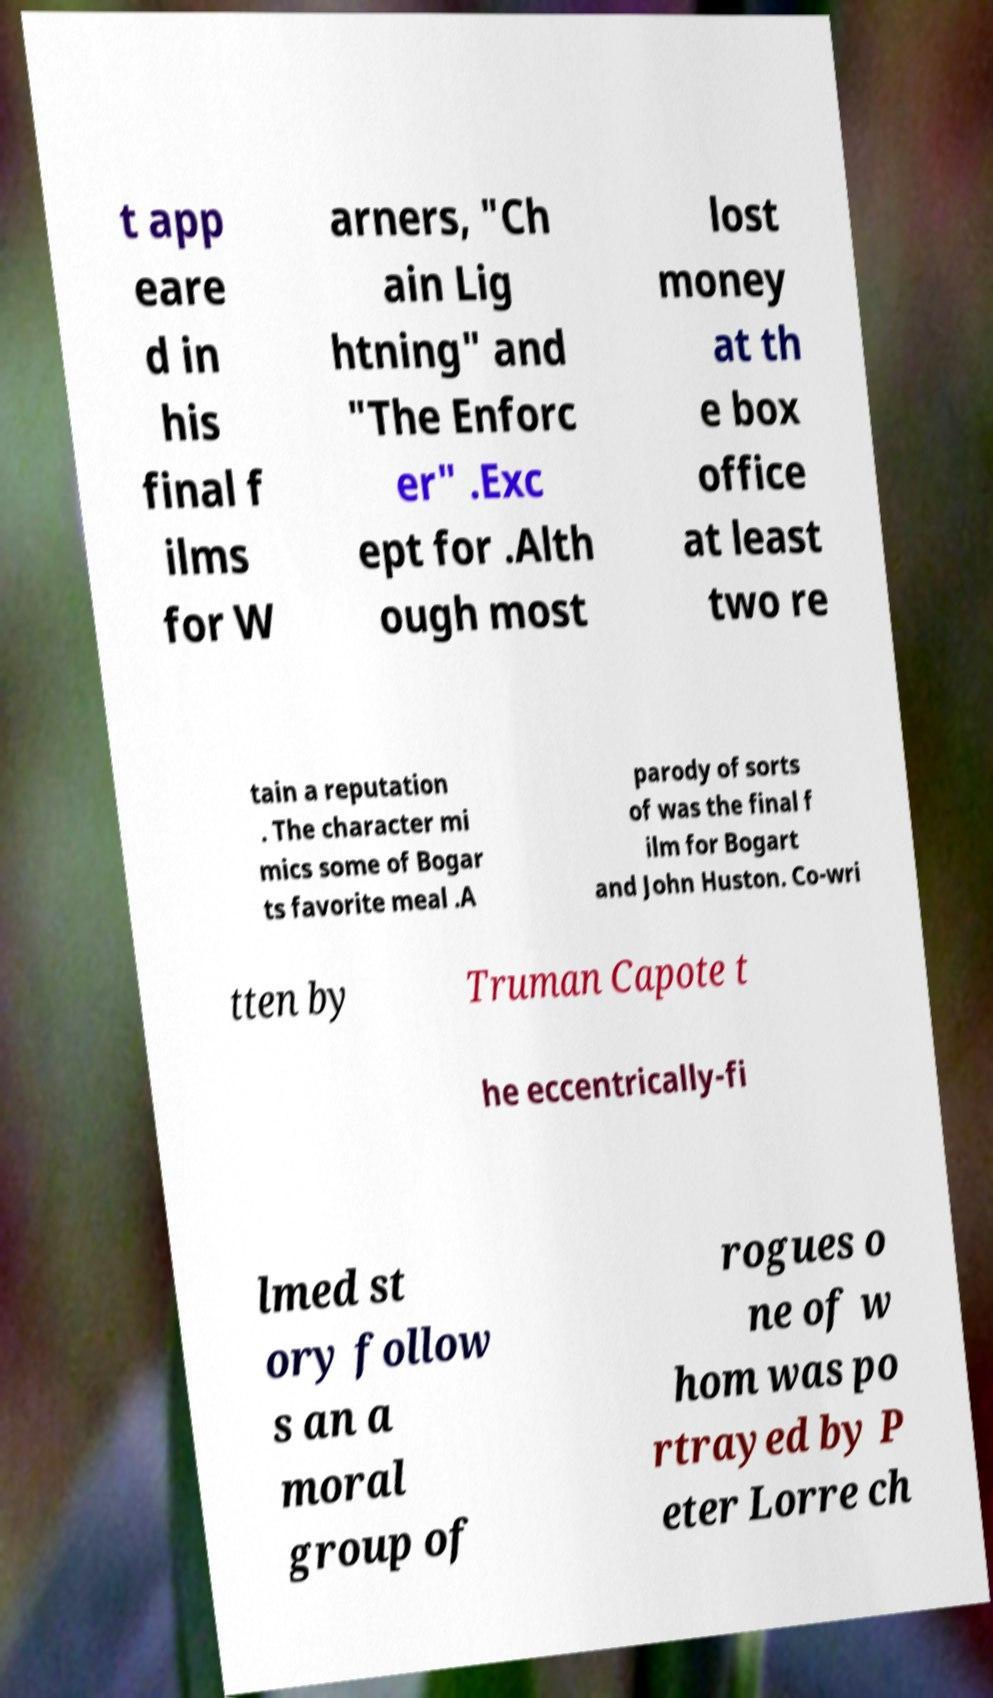What messages or text are displayed in this image? I need them in a readable, typed format. t app eare d in his final f ilms for W arners, "Ch ain Lig htning" and "The Enforc er" .Exc ept for .Alth ough most lost money at th e box office at least two re tain a reputation . The character mi mics some of Bogar ts favorite meal .A parody of sorts of was the final f ilm for Bogart and John Huston. Co-wri tten by Truman Capote t he eccentrically-fi lmed st ory follow s an a moral group of rogues o ne of w hom was po rtrayed by P eter Lorre ch 